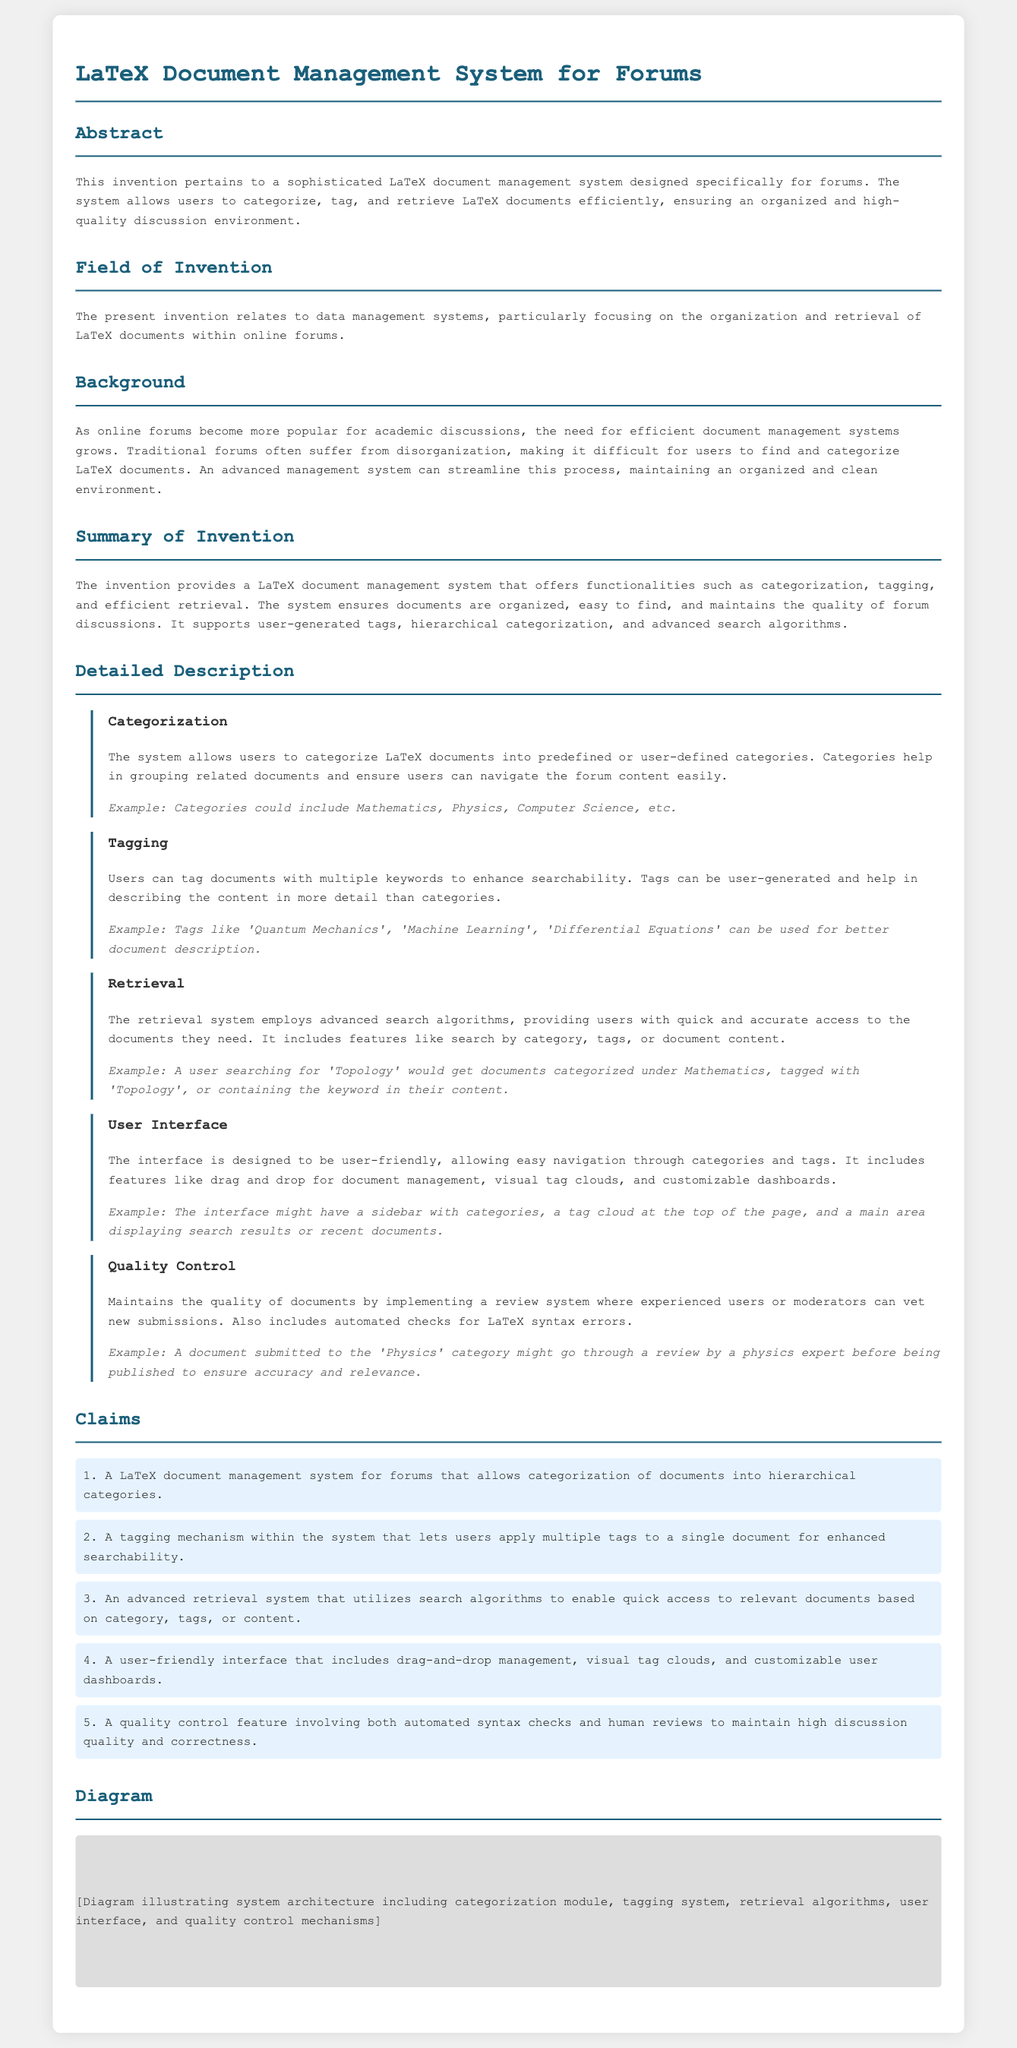What is the title of the patent application? The title can be found in the document's heading section.
Answer: LaTeX Document Management System for Forums What is the main purpose of the invention? The purpose is outlined in the abstract and summary sections of the document.
Answer: To allow users to categorize, tag, and retrieve LaTeX documents efficiently What field does the invention relate to? This information is provided in the "Field of Invention" section.
Answer: Data management systems What is one example of a predefined category mentioned? The examples are listed in the "Detailed Description" section under Categorization.
Answer: Mathematics How many claims are presented in the document? The number of claims is specified in the Claims section, where each claim is listed separately.
Answer: Five What feature does the quality control implement? The quality control mechanisms are described in the "Quality Control" subsection.
Answer: Review system What type of interface is mentioned in the document? This detail is elaborated in the "User Interface" subsection, highlighting interface characteristics.
Answer: User-friendly interface What is the example of a document tagging mentioned? The examples are provided in the "Tagging" subsection to describe tagging mechanism.
Answer: Quantum Mechanics What does the retrieval system utilize for document access? This information can be found in the "Retrieval" subsection, detailing how documents are accessed.
Answer: Search algorithms 